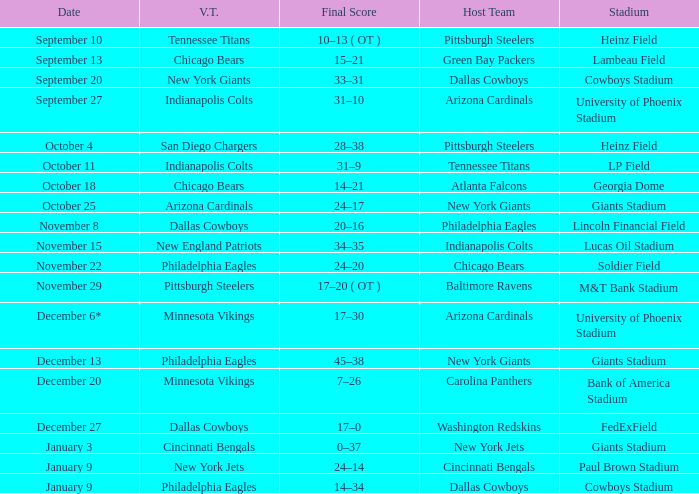I want to know the stadium for tennessee titans visiting Heinz Field. 